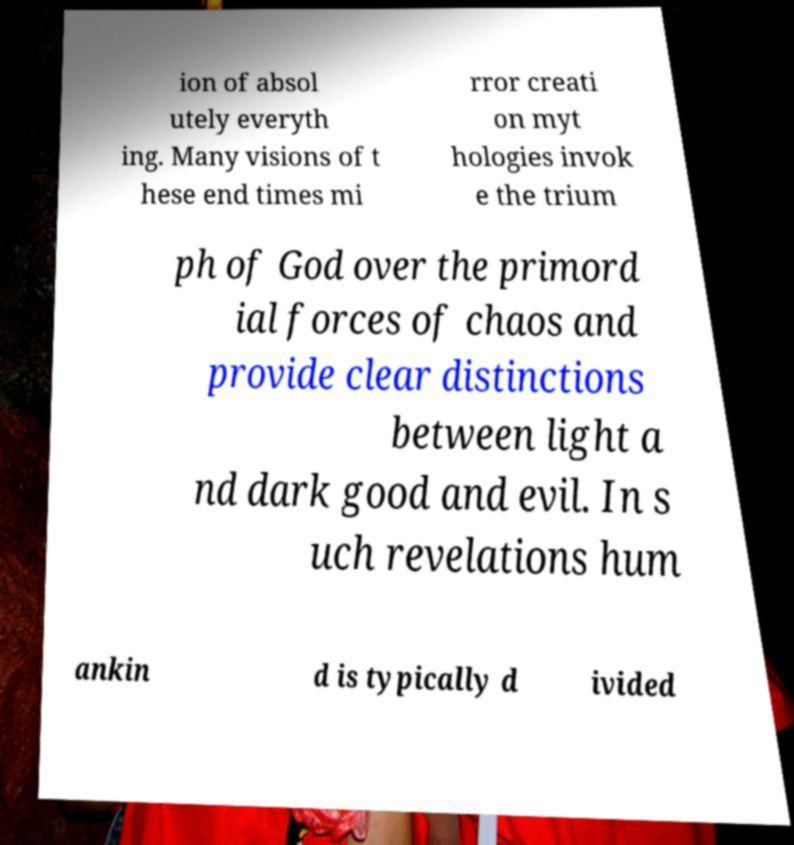For documentation purposes, I need the text within this image transcribed. Could you provide that? ion of absol utely everyth ing. Many visions of t hese end times mi rror creati on myt hologies invok e the trium ph of God over the primord ial forces of chaos and provide clear distinctions between light a nd dark good and evil. In s uch revelations hum ankin d is typically d ivided 